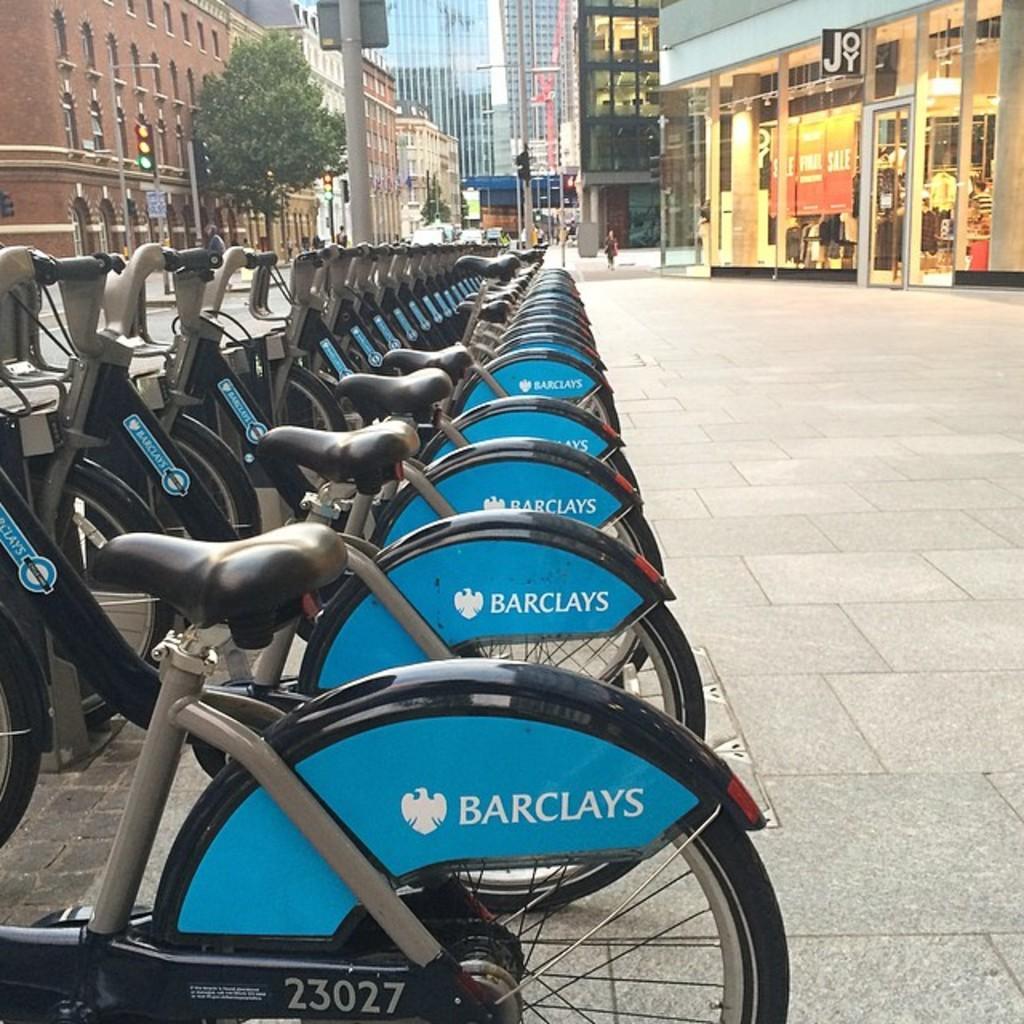How would you summarize this image in a sentence or two? In this picture we can see there are bicycle on the ground. Behind the bicycles, there are buildings, poles and trees. On the left side of the image, there is a pole with traffic signals. In the top right corner of the image, there is a banner and some objects inside the building. 